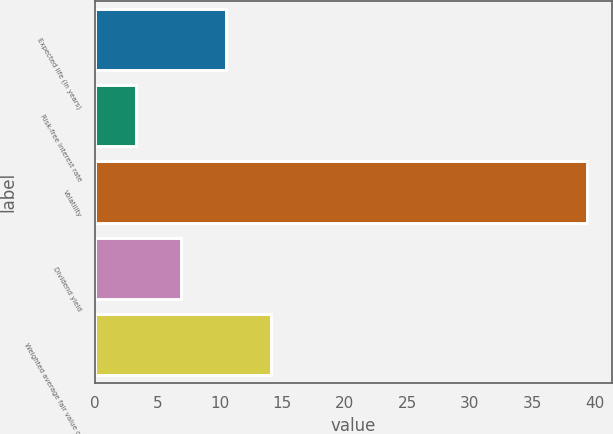Convert chart to OTSL. <chart><loc_0><loc_0><loc_500><loc_500><bar_chart><fcel>Expected life (in years)<fcel>Risk-free interest rate<fcel>Volatility<fcel>Dividend yield<fcel>Weighted average fair value of<nl><fcel>10.49<fcel>3.27<fcel>39.4<fcel>6.88<fcel>14.1<nl></chart> 